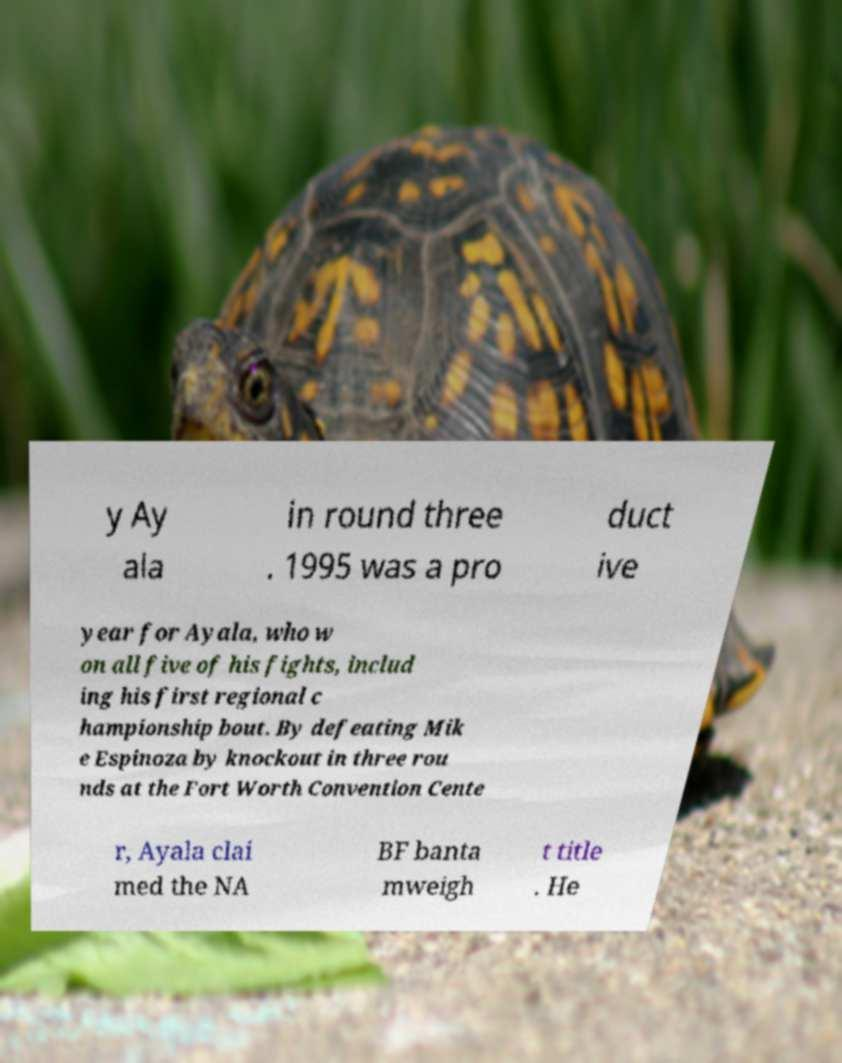Could you extract and type out the text from this image? y Ay ala in round three . 1995 was a pro duct ive year for Ayala, who w on all five of his fights, includ ing his first regional c hampionship bout. By defeating Mik e Espinoza by knockout in three rou nds at the Fort Worth Convention Cente r, Ayala clai med the NA BF banta mweigh t title . He 